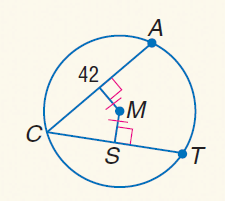Question: Find S C.
Choices:
A. 3
B. 7
C. 21
D. 42
Answer with the letter. Answer: C 